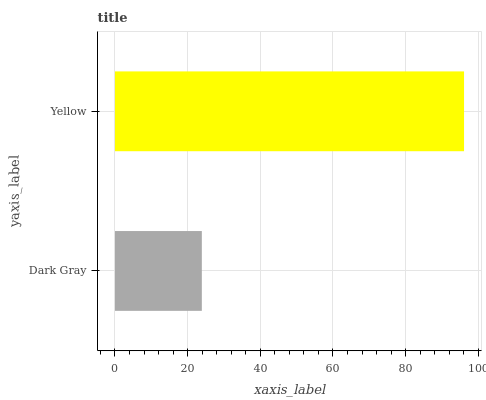Is Dark Gray the minimum?
Answer yes or no. Yes. Is Yellow the maximum?
Answer yes or no. Yes. Is Yellow the minimum?
Answer yes or no. No. Is Yellow greater than Dark Gray?
Answer yes or no. Yes. Is Dark Gray less than Yellow?
Answer yes or no. Yes. Is Dark Gray greater than Yellow?
Answer yes or no. No. Is Yellow less than Dark Gray?
Answer yes or no. No. Is Yellow the high median?
Answer yes or no. Yes. Is Dark Gray the low median?
Answer yes or no. Yes. Is Dark Gray the high median?
Answer yes or no. No. Is Yellow the low median?
Answer yes or no. No. 